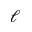Convert formula to latex. <formula><loc_0><loc_0><loc_500><loc_500>\ell</formula> 